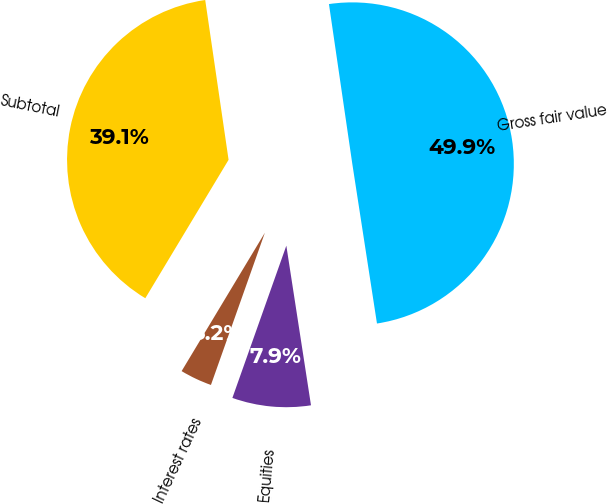Convert chart. <chart><loc_0><loc_0><loc_500><loc_500><pie_chart><fcel>Interest rates<fcel>Equities<fcel>Gross fair value<fcel>Subtotal<nl><fcel>3.2%<fcel>7.86%<fcel>49.87%<fcel>39.07%<nl></chart> 